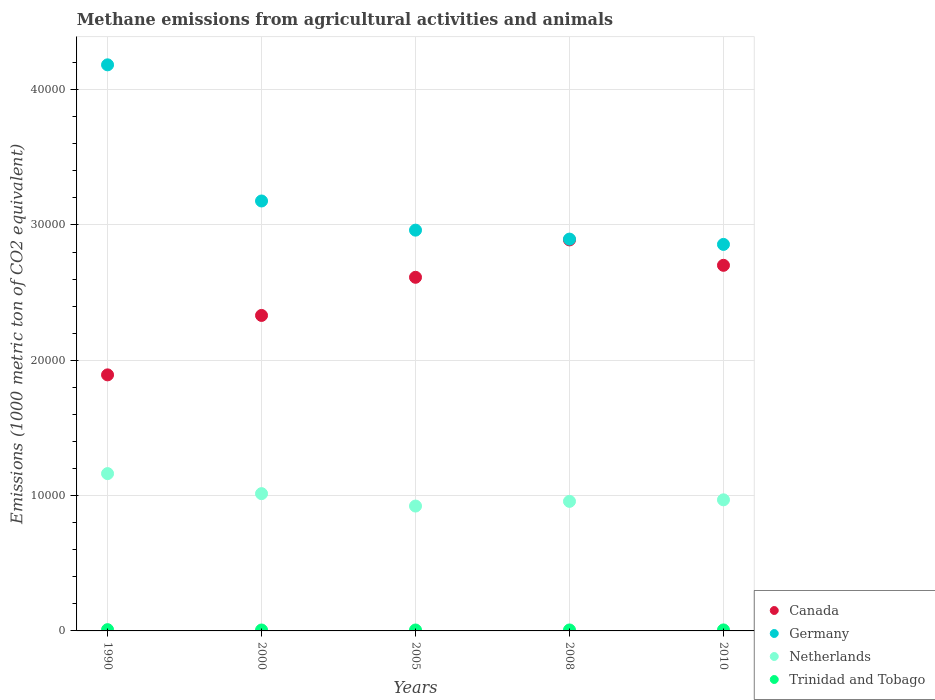How many different coloured dotlines are there?
Provide a succinct answer. 4. Is the number of dotlines equal to the number of legend labels?
Make the answer very short. Yes. What is the amount of methane emitted in Germany in 2008?
Ensure brevity in your answer.  2.90e+04. Across all years, what is the maximum amount of methane emitted in Canada?
Your response must be concise. 2.89e+04. Across all years, what is the minimum amount of methane emitted in Netherlands?
Offer a terse response. 9228. What is the total amount of methane emitted in Germany in the graph?
Give a very brief answer. 1.61e+05. What is the difference between the amount of methane emitted in Netherlands in 2000 and that in 2010?
Provide a succinct answer. 457. What is the difference between the amount of methane emitted in Canada in 2000 and the amount of methane emitted in Germany in 1990?
Keep it short and to the point. -1.85e+04. What is the average amount of methane emitted in Trinidad and Tobago per year?
Your answer should be very brief. 74.64. In the year 2005, what is the difference between the amount of methane emitted in Netherlands and amount of methane emitted in Germany?
Offer a terse response. -2.04e+04. In how many years, is the amount of methane emitted in Netherlands greater than 12000 1000 metric ton?
Your answer should be very brief. 0. What is the ratio of the amount of methane emitted in Trinidad and Tobago in 1990 to that in 2008?
Provide a short and direct response. 1.31. What is the difference between the highest and the second highest amount of methane emitted in Germany?
Your answer should be very brief. 1.01e+04. What is the difference between the highest and the lowest amount of methane emitted in Germany?
Offer a very short reply. 1.33e+04. Is the sum of the amount of methane emitted in Canada in 1990 and 2005 greater than the maximum amount of methane emitted in Trinidad and Tobago across all years?
Give a very brief answer. Yes. Is the amount of methane emitted in Canada strictly greater than the amount of methane emitted in Netherlands over the years?
Your answer should be very brief. Yes. Is the amount of methane emitted in Trinidad and Tobago strictly less than the amount of methane emitted in Canada over the years?
Provide a succinct answer. Yes. How many dotlines are there?
Provide a short and direct response. 4. How many years are there in the graph?
Your answer should be compact. 5. Does the graph contain any zero values?
Make the answer very short. No. What is the title of the graph?
Make the answer very short. Methane emissions from agricultural activities and animals. Does "Ukraine" appear as one of the legend labels in the graph?
Your answer should be very brief. No. What is the label or title of the X-axis?
Keep it short and to the point. Years. What is the label or title of the Y-axis?
Make the answer very short. Emissions (1000 metric ton of CO2 equivalent). What is the Emissions (1000 metric ton of CO2 equivalent) of Canada in 1990?
Your answer should be very brief. 1.89e+04. What is the Emissions (1000 metric ton of CO2 equivalent) in Germany in 1990?
Offer a terse response. 4.18e+04. What is the Emissions (1000 metric ton of CO2 equivalent) in Netherlands in 1990?
Provide a succinct answer. 1.16e+04. What is the Emissions (1000 metric ton of CO2 equivalent) in Trinidad and Tobago in 1990?
Your answer should be compact. 92.7. What is the Emissions (1000 metric ton of CO2 equivalent) in Canada in 2000?
Offer a very short reply. 2.33e+04. What is the Emissions (1000 metric ton of CO2 equivalent) in Germany in 2000?
Your response must be concise. 3.18e+04. What is the Emissions (1000 metric ton of CO2 equivalent) of Netherlands in 2000?
Your answer should be very brief. 1.01e+04. What is the Emissions (1000 metric ton of CO2 equivalent) of Trinidad and Tobago in 2000?
Your response must be concise. 68. What is the Emissions (1000 metric ton of CO2 equivalent) of Canada in 2005?
Ensure brevity in your answer.  2.61e+04. What is the Emissions (1000 metric ton of CO2 equivalent) of Germany in 2005?
Offer a very short reply. 2.96e+04. What is the Emissions (1000 metric ton of CO2 equivalent) of Netherlands in 2005?
Your answer should be compact. 9228. What is the Emissions (1000 metric ton of CO2 equivalent) of Trinidad and Tobago in 2005?
Provide a succinct answer. 68.1. What is the Emissions (1000 metric ton of CO2 equivalent) of Canada in 2008?
Provide a short and direct response. 2.89e+04. What is the Emissions (1000 metric ton of CO2 equivalent) of Germany in 2008?
Provide a succinct answer. 2.90e+04. What is the Emissions (1000 metric ton of CO2 equivalent) of Netherlands in 2008?
Ensure brevity in your answer.  9574.5. What is the Emissions (1000 metric ton of CO2 equivalent) in Canada in 2010?
Your response must be concise. 2.70e+04. What is the Emissions (1000 metric ton of CO2 equivalent) of Germany in 2010?
Offer a terse response. 2.86e+04. What is the Emissions (1000 metric ton of CO2 equivalent) of Netherlands in 2010?
Keep it short and to the point. 9687.8. What is the Emissions (1000 metric ton of CO2 equivalent) of Trinidad and Tobago in 2010?
Your answer should be very brief. 73.4. Across all years, what is the maximum Emissions (1000 metric ton of CO2 equivalent) in Canada?
Make the answer very short. 2.89e+04. Across all years, what is the maximum Emissions (1000 metric ton of CO2 equivalent) of Germany?
Keep it short and to the point. 4.18e+04. Across all years, what is the maximum Emissions (1000 metric ton of CO2 equivalent) in Netherlands?
Your answer should be compact. 1.16e+04. Across all years, what is the maximum Emissions (1000 metric ton of CO2 equivalent) in Trinidad and Tobago?
Make the answer very short. 92.7. Across all years, what is the minimum Emissions (1000 metric ton of CO2 equivalent) in Canada?
Your answer should be compact. 1.89e+04. Across all years, what is the minimum Emissions (1000 metric ton of CO2 equivalent) in Germany?
Ensure brevity in your answer.  2.86e+04. Across all years, what is the minimum Emissions (1000 metric ton of CO2 equivalent) in Netherlands?
Keep it short and to the point. 9228. What is the total Emissions (1000 metric ton of CO2 equivalent) of Canada in the graph?
Your answer should be very brief. 1.24e+05. What is the total Emissions (1000 metric ton of CO2 equivalent) of Germany in the graph?
Make the answer very short. 1.61e+05. What is the total Emissions (1000 metric ton of CO2 equivalent) in Netherlands in the graph?
Give a very brief answer. 5.03e+04. What is the total Emissions (1000 metric ton of CO2 equivalent) in Trinidad and Tobago in the graph?
Your response must be concise. 373.2. What is the difference between the Emissions (1000 metric ton of CO2 equivalent) of Canada in 1990 and that in 2000?
Keep it short and to the point. -4391.7. What is the difference between the Emissions (1000 metric ton of CO2 equivalent) of Germany in 1990 and that in 2000?
Offer a terse response. 1.01e+04. What is the difference between the Emissions (1000 metric ton of CO2 equivalent) of Netherlands in 1990 and that in 2000?
Keep it short and to the point. 1481.2. What is the difference between the Emissions (1000 metric ton of CO2 equivalent) of Trinidad and Tobago in 1990 and that in 2000?
Provide a succinct answer. 24.7. What is the difference between the Emissions (1000 metric ton of CO2 equivalent) in Canada in 1990 and that in 2005?
Offer a very short reply. -7210.8. What is the difference between the Emissions (1000 metric ton of CO2 equivalent) of Germany in 1990 and that in 2005?
Keep it short and to the point. 1.22e+04. What is the difference between the Emissions (1000 metric ton of CO2 equivalent) of Netherlands in 1990 and that in 2005?
Offer a very short reply. 2398. What is the difference between the Emissions (1000 metric ton of CO2 equivalent) in Trinidad and Tobago in 1990 and that in 2005?
Make the answer very short. 24.6. What is the difference between the Emissions (1000 metric ton of CO2 equivalent) in Canada in 1990 and that in 2008?
Ensure brevity in your answer.  -9973.1. What is the difference between the Emissions (1000 metric ton of CO2 equivalent) of Germany in 1990 and that in 2008?
Your answer should be very brief. 1.29e+04. What is the difference between the Emissions (1000 metric ton of CO2 equivalent) in Netherlands in 1990 and that in 2008?
Your response must be concise. 2051.5. What is the difference between the Emissions (1000 metric ton of CO2 equivalent) in Trinidad and Tobago in 1990 and that in 2008?
Offer a very short reply. 21.7. What is the difference between the Emissions (1000 metric ton of CO2 equivalent) of Canada in 1990 and that in 2010?
Offer a terse response. -8095.8. What is the difference between the Emissions (1000 metric ton of CO2 equivalent) in Germany in 1990 and that in 2010?
Your answer should be very brief. 1.33e+04. What is the difference between the Emissions (1000 metric ton of CO2 equivalent) of Netherlands in 1990 and that in 2010?
Offer a terse response. 1938.2. What is the difference between the Emissions (1000 metric ton of CO2 equivalent) in Trinidad and Tobago in 1990 and that in 2010?
Offer a terse response. 19.3. What is the difference between the Emissions (1000 metric ton of CO2 equivalent) of Canada in 2000 and that in 2005?
Your answer should be very brief. -2819.1. What is the difference between the Emissions (1000 metric ton of CO2 equivalent) in Germany in 2000 and that in 2005?
Provide a short and direct response. 2155.4. What is the difference between the Emissions (1000 metric ton of CO2 equivalent) in Netherlands in 2000 and that in 2005?
Offer a very short reply. 916.8. What is the difference between the Emissions (1000 metric ton of CO2 equivalent) in Trinidad and Tobago in 2000 and that in 2005?
Make the answer very short. -0.1. What is the difference between the Emissions (1000 metric ton of CO2 equivalent) in Canada in 2000 and that in 2008?
Offer a very short reply. -5581.4. What is the difference between the Emissions (1000 metric ton of CO2 equivalent) in Germany in 2000 and that in 2008?
Your response must be concise. 2816.4. What is the difference between the Emissions (1000 metric ton of CO2 equivalent) of Netherlands in 2000 and that in 2008?
Offer a terse response. 570.3. What is the difference between the Emissions (1000 metric ton of CO2 equivalent) of Trinidad and Tobago in 2000 and that in 2008?
Make the answer very short. -3. What is the difference between the Emissions (1000 metric ton of CO2 equivalent) of Canada in 2000 and that in 2010?
Your answer should be very brief. -3704.1. What is the difference between the Emissions (1000 metric ton of CO2 equivalent) of Germany in 2000 and that in 2010?
Offer a terse response. 3209.1. What is the difference between the Emissions (1000 metric ton of CO2 equivalent) of Netherlands in 2000 and that in 2010?
Keep it short and to the point. 457. What is the difference between the Emissions (1000 metric ton of CO2 equivalent) of Canada in 2005 and that in 2008?
Provide a short and direct response. -2762.3. What is the difference between the Emissions (1000 metric ton of CO2 equivalent) of Germany in 2005 and that in 2008?
Make the answer very short. 661. What is the difference between the Emissions (1000 metric ton of CO2 equivalent) in Netherlands in 2005 and that in 2008?
Provide a succinct answer. -346.5. What is the difference between the Emissions (1000 metric ton of CO2 equivalent) of Canada in 2005 and that in 2010?
Offer a terse response. -885. What is the difference between the Emissions (1000 metric ton of CO2 equivalent) in Germany in 2005 and that in 2010?
Make the answer very short. 1053.7. What is the difference between the Emissions (1000 metric ton of CO2 equivalent) in Netherlands in 2005 and that in 2010?
Make the answer very short. -459.8. What is the difference between the Emissions (1000 metric ton of CO2 equivalent) in Canada in 2008 and that in 2010?
Provide a short and direct response. 1877.3. What is the difference between the Emissions (1000 metric ton of CO2 equivalent) in Germany in 2008 and that in 2010?
Your answer should be very brief. 392.7. What is the difference between the Emissions (1000 metric ton of CO2 equivalent) of Netherlands in 2008 and that in 2010?
Offer a very short reply. -113.3. What is the difference between the Emissions (1000 metric ton of CO2 equivalent) of Canada in 1990 and the Emissions (1000 metric ton of CO2 equivalent) of Germany in 2000?
Provide a short and direct response. -1.29e+04. What is the difference between the Emissions (1000 metric ton of CO2 equivalent) of Canada in 1990 and the Emissions (1000 metric ton of CO2 equivalent) of Netherlands in 2000?
Give a very brief answer. 8778.7. What is the difference between the Emissions (1000 metric ton of CO2 equivalent) of Canada in 1990 and the Emissions (1000 metric ton of CO2 equivalent) of Trinidad and Tobago in 2000?
Provide a short and direct response. 1.89e+04. What is the difference between the Emissions (1000 metric ton of CO2 equivalent) of Germany in 1990 and the Emissions (1000 metric ton of CO2 equivalent) of Netherlands in 2000?
Keep it short and to the point. 3.17e+04. What is the difference between the Emissions (1000 metric ton of CO2 equivalent) in Germany in 1990 and the Emissions (1000 metric ton of CO2 equivalent) in Trinidad and Tobago in 2000?
Provide a succinct answer. 4.18e+04. What is the difference between the Emissions (1000 metric ton of CO2 equivalent) in Netherlands in 1990 and the Emissions (1000 metric ton of CO2 equivalent) in Trinidad and Tobago in 2000?
Your answer should be compact. 1.16e+04. What is the difference between the Emissions (1000 metric ton of CO2 equivalent) of Canada in 1990 and the Emissions (1000 metric ton of CO2 equivalent) of Germany in 2005?
Your response must be concise. -1.07e+04. What is the difference between the Emissions (1000 metric ton of CO2 equivalent) of Canada in 1990 and the Emissions (1000 metric ton of CO2 equivalent) of Netherlands in 2005?
Ensure brevity in your answer.  9695.5. What is the difference between the Emissions (1000 metric ton of CO2 equivalent) in Canada in 1990 and the Emissions (1000 metric ton of CO2 equivalent) in Trinidad and Tobago in 2005?
Your answer should be very brief. 1.89e+04. What is the difference between the Emissions (1000 metric ton of CO2 equivalent) in Germany in 1990 and the Emissions (1000 metric ton of CO2 equivalent) in Netherlands in 2005?
Your answer should be very brief. 3.26e+04. What is the difference between the Emissions (1000 metric ton of CO2 equivalent) in Germany in 1990 and the Emissions (1000 metric ton of CO2 equivalent) in Trinidad and Tobago in 2005?
Your response must be concise. 4.18e+04. What is the difference between the Emissions (1000 metric ton of CO2 equivalent) in Netherlands in 1990 and the Emissions (1000 metric ton of CO2 equivalent) in Trinidad and Tobago in 2005?
Offer a terse response. 1.16e+04. What is the difference between the Emissions (1000 metric ton of CO2 equivalent) in Canada in 1990 and the Emissions (1000 metric ton of CO2 equivalent) in Germany in 2008?
Provide a short and direct response. -1.00e+04. What is the difference between the Emissions (1000 metric ton of CO2 equivalent) in Canada in 1990 and the Emissions (1000 metric ton of CO2 equivalent) in Netherlands in 2008?
Ensure brevity in your answer.  9349. What is the difference between the Emissions (1000 metric ton of CO2 equivalent) of Canada in 1990 and the Emissions (1000 metric ton of CO2 equivalent) of Trinidad and Tobago in 2008?
Your response must be concise. 1.89e+04. What is the difference between the Emissions (1000 metric ton of CO2 equivalent) in Germany in 1990 and the Emissions (1000 metric ton of CO2 equivalent) in Netherlands in 2008?
Your response must be concise. 3.23e+04. What is the difference between the Emissions (1000 metric ton of CO2 equivalent) of Germany in 1990 and the Emissions (1000 metric ton of CO2 equivalent) of Trinidad and Tobago in 2008?
Your answer should be compact. 4.18e+04. What is the difference between the Emissions (1000 metric ton of CO2 equivalent) of Netherlands in 1990 and the Emissions (1000 metric ton of CO2 equivalent) of Trinidad and Tobago in 2008?
Offer a very short reply. 1.16e+04. What is the difference between the Emissions (1000 metric ton of CO2 equivalent) of Canada in 1990 and the Emissions (1000 metric ton of CO2 equivalent) of Germany in 2010?
Provide a short and direct response. -9641. What is the difference between the Emissions (1000 metric ton of CO2 equivalent) of Canada in 1990 and the Emissions (1000 metric ton of CO2 equivalent) of Netherlands in 2010?
Give a very brief answer. 9235.7. What is the difference between the Emissions (1000 metric ton of CO2 equivalent) of Canada in 1990 and the Emissions (1000 metric ton of CO2 equivalent) of Trinidad and Tobago in 2010?
Keep it short and to the point. 1.89e+04. What is the difference between the Emissions (1000 metric ton of CO2 equivalent) of Germany in 1990 and the Emissions (1000 metric ton of CO2 equivalent) of Netherlands in 2010?
Ensure brevity in your answer.  3.21e+04. What is the difference between the Emissions (1000 metric ton of CO2 equivalent) in Germany in 1990 and the Emissions (1000 metric ton of CO2 equivalent) in Trinidad and Tobago in 2010?
Offer a very short reply. 4.18e+04. What is the difference between the Emissions (1000 metric ton of CO2 equivalent) in Netherlands in 1990 and the Emissions (1000 metric ton of CO2 equivalent) in Trinidad and Tobago in 2010?
Your answer should be very brief. 1.16e+04. What is the difference between the Emissions (1000 metric ton of CO2 equivalent) in Canada in 2000 and the Emissions (1000 metric ton of CO2 equivalent) in Germany in 2005?
Offer a very short reply. -6303. What is the difference between the Emissions (1000 metric ton of CO2 equivalent) of Canada in 2000 and the Emissions (1000 metric ton of CO2 equivalent) of Netherlands in 2005?
Make the answer very short. 1.41e+04. What is the difference between the Emissions (1000 metric ton of CO2 equivalent) of Canada in 2000 and the Emissions (1000 metric ton of CO2 equivalent) of Trinidad and Tobago in 2005?
Your answer should be compact. 2.32e+04. What is the difference between the Emissions (1000 metric ton of CO2 equivalent) of Germany in 2000 and the Emissions (1000 metric ton of CO2 equivalent) of Netherlands in 2005?
Provide a short and direct response. 2.25e+04. What is the difference between the Emissions (1000 metric ton of CO2 equivalent) in Germany in 2000 and the Emissions (1000 metric ton of CO2 equivalent) in Trinidad and Tobago in 2005?
Ensure brevity in your answer.  3.17e+04. What is the difference between the Emissions (1000 metric ton of CO2 equivalent) in Netherlands in 2000 and the Emissions (1000 metric ton of CO2 equivalent) in Trinidad and Tobago in 2005?
Your answer should be very brief. 1.01e+04. What is the difference between the Emissions (1000 metric ton of CO2 equivalent) in Canada in 2000 and the Emissions (1000 metric ton of CO2 equivalent) in Germany in 2008?
Provide a short and direct response. -5642. What is the difference between the Emissions (1000 metric ton of CO2 equivalent) in Canada in 2000 and the Emissions (1000 metric ton of CO2 equivalent) in Netherlands in 2008?
Keep it short and to the point. 1.37e+04. What is the difference between the Emissions (1000 metric ton of CO2 equivalent) in Canada in 2000 and the Emissions (1000 metric ton of CO2 equivalent) in Trinidad and Tobago in 2008?
Offer a very short reply. 2.32e+04. What is the difference between the Emissions (1000 metric ton of CO2 equivalent) in Germany in 2000 and the Emissions (1000 metric ton of CO2 equivalent) in Netherlands in 2008?
Offer a very short reply. 2.22e+04. What is the difference between the Emissions (1000 metric ton of CO2 equivalent) in Germany in 2000 and the Emissions (1000 metric ton of CO2 equivalent) in Trinidad and Tobago in 2008?
Your answer should be very brief. 3.17e+04. What is the difference between the Emissions (1000 metric ton of CO2 equivalent) in Netherlands in 2000 and the Emissions (1000 metric ton of CO2 equivalent) in Trinidad and Tobago in 2008?
Offer a very short reply. 1.01e+04. What is the difference between the Emissions (1000 metric ton of CO2 equivalent) in Canada in 2000 and the Emissions (1000 metric ton of CO2 equivalent) in Germany in 2010?
Your answer should be very brief. -5249.3. What is the difference between the Emissions (1000 metric ton of CO2 equivalent) of Canada in 2000 and the Emissions (1000 metric ton of CO2 equivalent) of Netherlands in 2010?
Provide a short and direct response. 1.36e+04. What is the difference between the Emissions (1000 metric ton of CO2 equivalent) of Canada in 2000 and the Emissions (1000 metric ton of CO2 equivalent) of Trinidad and Tobago in 2010?
Ensure brevity in your answer.  2.32e+04. What is the difference between the Emissions (1000 metric ton of CO2 equivalent) of Germany in 2000 and the Emissions (1000 metric ton of CO2 equivalent) of Netherlands in 2010?
Offer a terse response. 2.21e+04. What is the difference between the Emissions (1000 metric ton of CO2 equivalent) of Germany in 2000 and the Emissions (1000 metric ton of CO2 equivalent) of Trinidad and Tobago in 2010?
Provide a short and direct response. 3.17e+04. What is the difference between the Emissions (1000 metric ton of CO2 equivalent) in Netherlands in 2000 and the Emissions (1000 metric ton of CO2 equivalent) in Trinidad and Tobago in 2010?
Give a very brief answer. 1.01e+04. What is the difference between the Emissions (1000 metric ton of CO2 equivalent) of Canada in 2005 and the Emissions (1000 metric ton of CO2 equivalent) of Germany in 2008?
Your answer should be compact. -2822.9. What is the difference between the Emissions (1000 metric ton of CO2 equivalent) of Canada in 2005 and the Emissions (1000 metric ton of CO2 equivalent) of Netherlands in 2008?
Your answer should be compact. 1.66e+04. What is the difference between the Emissions (1000 metric ton of CO2 equivalent) of Canada in 2005 and the Emissions (1000 metric ton of CO2 equivalent) of Trinidad and Tobago in 2008?
Keep it short and to the point. 2.61e+04. What is the difference between the Emissions (1000 metric ton of CO2 equivalent) of Germany in 2005 and the Emissions (1000 metric ton of CO2 equivalent) of Netherlands in 2008?
Offer a very short reply. 2.00e+04. What is the difference between the Emissions (1000 metric ton of CO2 equivalent) in Germany in 2005 and the Emissions (1000 metric ton of CO2 equivalent) in Trinidad and Tobago in 2008?
Keep it short and to the point. 2.95e+04. What is the difference between the Emissions (1000 metric ton of CO2 equivalent) of Netherlands in 2005 and the Emissions (1000 metric ton of CO2 equivalent) of Trinidad and Tobago in 2008?
Offer a very short reply. 9157. What is the difference between the Emissions (1000 metric ton of CO2 equivalent) of Canada in 2005 and the Emissions (1000 metric ton of CO2 equivalent) of Germany in 2010?
Provide a short and direct response. -2430.2. What is the difference between the Emissions (1000 metric ton of CO2 equivalent) in Canada in 2005 and the Emissions (1000 metric ton of CO2 equivalent) in Netherlands in 2010?
Offer a terse response. 1.64e+04. What is the difference between the Emissions (1000 metric ton of CO2 equivalent) in Canada in 2005 and the Emissions (1000 metric ton of CO2 equivalent) in Trinidad and Tobago in 2010?
Your answer should be very brief. 2.61e+04. What is the difference between the Emissions (1000 metric ton of CO2 equivalent) in Germany in 2005 and the Emissions (1000 metric ton of CO2 equivalent) in Netherlands in 2010?
Offer a very short reply. 1.99e+04. What is the difference between the Emissions (1000 metric ton of CO2 equivalent) of Germany in 2005 and the Emissions (1000 metric ton of CO2 equivalent) of Trinidad and Tobago in 2010?
Your answer should be very brief. 2.95e+04. What is the difference between the Emissions (1000 metric ton of CO2 equivalent) of Netherlands in 2005 and the Emissions (1000 metric ton of CO2 equivalent) of Trinidad and Tobago in 2010?
Provide a short and direct response. 9154.6. What is the difference between the Emissions (1000 metric ton of CO2 equivalent) of Canada in 2008 and the Emissions (1000 metric ton of CO2 equivalent) of Germany in 2010?
Keep it short and to the point. 332.1. What is the difference between the Emissions (1000 metric ton of CO2 equivalent) in Canada in 2008 and the Emissions (1000 metric ton of CO2 equivalent) in Netherlands in 2010?
Make the answer very short. 1.92e+04. What is the difference between the Emissions (1000 metric ton of CO2 equivalent) of Canada in 2008 and the Emissions (1000 metric ton of CO2 equivalent) of Trinidad and Tobago in 2010?
Your answer should be very brief. 2.88e+04. What is the difference between the Emissions (1000 metric ton of CO2 equivalent) in Germany in 2008 and the Emissions (1000 metric ton of CO2 equivalent) in Netherlands in 2010?
Offer a very short reply. 1.93e+04. What is the difference between the Emissions (1000 metric ton of CO2 equivalent) in Germany in 2008 and the Emissions (1000 metric ton of CO2 equivalent) in Trinidad and Tobago in 2010?
Your answer should be compact. 2.89e+04. What is the difference between the Emissions (1000 metric ton of CO2 equivalent) in Netherlands in 2008 and the Emissions (1000 metric ton of CO2 equivalent) in Trinidad and Tobago in 2010?
Make the answer very short. 9501.1. What is the average Emissions (1000 metric ton of CO2 equivalent) in Canada per year?
Your answer should be very brief. 2.49e+04. What is the average Emissions (1000 metric ton of CO2 equivalent) in Germany per year?
Make the answer very short. 3.21e+04. What is the average Emissions (1000 metric ton of CO2 equivalent) of Netherlands per year?
Offer a very short reply. 1.01e+04. What is the average Emissions (1000 metric ton of CO2 equivalent) of Trinidad and Tobago per year?
Make the answer very short. 74.64. In the year 1990, what is the difference between the Emissions (1000 metric ton of CO2 equivalent) of Canada and Emissions (1000 metric ton of CO2 equivalent) of Germany?
Make the answer very short. -2.29e+04. In the year 1990, what is the difference between the Emissions (1000 metric ton of CO2 equivalent) of Canada and Emissions (1000 metric ton of CO2 equivalent) of Netherlands?
Offer a terse response. 7297.5. In the year 1990, what is the difference between the Emissions (1000 metric ton of CO2 equivalent) of Canada and Emissions (1000 metric ton of CO2 equivalent) of Trinidad and Tobago?
Your answer should be compact. 1.88e+04. In the year 1990, what is the difference between the Emissions (1000 metric ton of CO2 equivalent) in Germany and Emissions (1000 metric ton of CO2 equivalent) in Netherlands?
Offer a terse response. 3.02e+04. In the year 1990, what is the difference between the Emissions (1000 metric ton of CO2 equivalent) in Germany and Emissions (1000 metric ton of CO2 equivalent) in Trinidad and Tobago?
Your response must be concise. 4.17e+04. In the year 1990, what is the difference between the Emissions (1000 metric ton of CO2 equivalent) of Netherlands and Emissions (1000 metric ton of CO2 equivalent) of Trinidad and Tobago?
Your answer should be very brief. 1.15e+04. In the year 2000, what is the difference between the Emissions (1000 metric ton of CO2 equivalent) of Canada and Emissions (1000 metric ton of CO2 equivalent) of Germany?
Provide a short and direct response. -8458.4. In the year 2000, what is the difference between the Emissions (1000 metric ton of CO2 equivalent) of Canada and Emissions (1000 metric ton of CO2 equivalent) of Netherlands?
Provide a short and direct response. 1.32e+04. In the year 2000, what is the difference between the Emissions (1000 metric ton of CO2 equivalent) of Canada and Emissions (1000 metric ton of CO2 equivalent) of Trinidad and Tobago?
Provide a short and direct response. 2.32e+04. In the year 2000, what is the difference between the Emissions (1000 metric ton of CO2 equivalent) of Germany and Emissions (1000 metric ton of CO2 equivalent) of Netherlands?
Give a very brief answer. 2.16e+04. In the year 2000, what is the difference between the Emissions (1000 metric ton of CO2 equivalent) of Germany and Emissions (1000 metric ton of CO2 equivalent) of Trinidad and Tobago?
Your answer should be very brief. 3.17e+04. In the year 2000, what is the difference between the Emissions (1000 metric ton of CO2 equivalent) in Netherlands and Emissions (1000 metric ton of CO2 equivalent) in Trinidad and Tobago?
Ensure brevity in your answer.  1.01e+04. In the year 2005, what is the difference between the Emissions (1000 metric ton of CO2 equivalent) of Canada and Emissions (1000 metric ton of CO2 equivalent) of Germany?
Keep it short and to the point. -3483.9. In the year 2005, what is the difference between the Emissions (1000 metric ton of CO2 equivalent) in Canada and Emissions (1000 metric ton of CO2 equivalent) in Netherlands?
Provide a short and direct response. 1.69e+04. In the year 2005, what is the difference between the Emissions (1000 metric ton of CO2 equivalent) of Canada and Emissions (1000 metric ton of CO2 equivalent) of Trinidad and Tobago?
Provide a short and direct response. 2.61e+04. In the year 2005, what is the difference between the Emissions (1000 metric ton of CO2 equivalent) of Germany and Emissions (1000 metric ton of CO2 equivalent) of Netherlands?
Provide a short and direct response. 2.04e+04. In the year 2005, what is the difference between the Emissions (1000 metric ton of CO2 equivalent) of Germany and Emissions (1000 metric ton of CO2 equivalent) of Trinidad and Tobago?
Offer a very short reply. 2.96e+04. In the year 2005, what is the difference between the Emissions (1000 metric ton of CO2 equivalent) of Netherlands and Emissions (1000 metric ton of CO2 equivalent) of Trinidad and Tobago?
Offer a very short reply. 9159.9. In the year 2008, what is the difference between the Emissions (1000 metric ton of CO2 equivalent) of Canada and Emissions (1000 metric ton of CO2 equivalent) of Germany?
Give a very brief answer. -60.6. In the year 2008, what is the difference between the Emissions (1000 metric ton of CO2 equivalent) of Canada and Emissions (1000 metric ton of CO2 equivalent) of Netherlands?
Keep it short and to the point. 1.93e+04. In the year 2008, what is the difference between the Emissions (1000 metric ton of CO2 equivalent) in Canada and Emissions (1000 metric ton of CO2 equivalent) in Trinidad and Tobago?
Keep it short and to the point. 2.88e+04. In the year 2008, what is the difference between the Emissions (1000 metric ton of CO2 equivalent) of Germany and Emissions (1000 metric ton of CO2 equivalent) of Netherlands?
Offer a terse response. 1.94e+04. In the year 2008, what is the difference between the Emissions (1000 metric ton of CO2 equivalent) in Germany and Emissions (1000 metric ton of CO2 equivalent) in Trinidad and Tobago?
Your answer should be compact. 2.89e+04. In the year 2008, what is the difference between the Emissions (1000 metric ton of CO2 equivalent) in Netherlands and Emissions (1000 metric ton of CO2 equivalent) in Trinidad and Tobago?
Offer a very short reply. 9503.5. In the year 2010, what is the difference between the Emissions (1000 metric ton of CO2 equivalent) of Canada and Emissions (1000 metric ton of CO2 equivalent) of Germany?
Your response must be concise. -1545.2. In the year 2010, what is the difference between the Emissions (1000 metric ton of CO2 equivalent) in Canada and Emissions (1000 metric ton of CO2 equivalent) in Netherlands?
Offer a terse response. 1.73e+04. In the year 2010, what is the difference between the Emissions (1000 metric ton of CO2 equivalent) of Canada and Emissions (1000 metric ton of CO2 equivalent) of Trinidad and Tobago?
Your response must be concise. 2.69e+04. In the year 2010, what is the difference between the Emissions (1000 metric ton of CO2 equivalent) in Germany and Emissions (1000 metric ton of CO2 equivalent) in Netherlands?
Keep it short and to the point. 1.89e+04. In the year 2010, what is the difference between the Emissions (1000 metric ton of CO2 equivalent) of Germany and Emissions (1000 metric ton of CO2 equivalent) of Trinidad and Tobago?
Give a very brief answer. 2.85e+04. In the year 2010, what is the difference between the Emissions (1000 metric ton of CO2 equivalent) of Netherlands and Emissions (1000 metric ton of CO2 equivalent) of Trinidad and Tobago?
Offer a very short reply. 9614.4. What is the ratio of the Emissions (1000 metric ton of CO2 equivalent) in Canada in 1990 to that in 2000?
Give a very brief answer. 0.81. What is the ratio of the Emissions (1000 metric ton of CO2 equivalent) in Germany in 1990 to that in 2000?
Your response must be concise. 1.32. What is the ratio of the Emissions (1000 metric ton of CO2 equivalent) of Netherlands in 1990 to that in 2000?
Your answer should be compact. 1.15. What is the ratio of the Emissions (1000 metric ton of CO2 equivalent) of Trinidad and Tobago in 1990 to that in 2000?
Keep it short and to the point. 1.36. What is the ratio of the Emissions (1000 metric ton of CO2 equivalent) of Canada in 1990 to that in 2005?
Ensure brevity in your answer.  0.72. What is the ratio of the Emissions (1000 metric ton of CO2 equivalent) in Germany in 1990 to that in 2005?
Ensure brevity in your answer.  1.41. What is the ratio of the Emissions (1000 metric ton of CO2 equivalent) of Netherlands in 1990 to that in 2005?
Provide a short and direct response. 1.26. What is the ratio of the Emissions (1000 metric ton of CO2 equivalent) of Trinidad and Tobago in 1990 to that in 2005?
Offer a very short reply. 1.36. What is the ratio of the Emissions (1000 metric ton of CO2 equivalent) in Canada in 1990 to that in 2008?
Keep it short and to the point. 0.65. What is the ratio of the Emissions (1000 metric ton of CO2 equivalent) in Germany in 1990 to that in 2008?
Make the answer very short. 1.44. What is the ratio of the Emissions (1000 metric ton of CO2 equivalent) of Netherlands in 1990 to that in 2008?
Offer a very short reply. 1.21. What is the ratio of the Emissions (1000 metric ton of CO2 equivalent) of Trinidad and Tobago in 1990 to that in 2008?
Offer a terse response. 1.31. What is the ratio of the Emissions (1000 metric ton of CO2 equivalent) in Canada in 1990 to that in 2010?
Your answer should be very brief. 0.7. What is the ratio of the Emissions (1000 metric ton of CO2 equivalent) in Germany in 1990 to that in 2010?
Ensure brevity in your answer.  1.46. What is the ratio of the Emissions (1000 metric ton of CO2 equivalent) in Netherlands in 1990 to that in 2010?
Keep it short and to the point. 1.2. What is the ratio of the Emissions (1000 metric ton of CO2 equivalent) in Trinidad and Tobago in 1990 to that in 2010?
Keep it short and to the point. 1.26. What is the ratio of the Emissions (1000 metric ton of CO2 equivalent) in Canada in 2000 to that in 2005?
Your response must be concise. 0.89. What is the ratio of the Emissions (1000 metric ton of CO2 equivalent) in Germany in 2000 to that in 2005?
Offer a terse response. 1.07. What is the ratio of the Emissions (1000 metric ton of CO2 equivalent) in Netherlands in 2000 to that in 2005?
Your answer should be very brief. 1.1. What is the ratio of the Emissions (1000 metric ton of CO2 equivalent) of Canada in 2000 to that in 2008?
Provide a succinct answer. 0.81. What is the ratio of the Emissions (1000 metric ton of CO2 equivalent) of Germany in 2000 to that in 2008?
Give a very brief answer. 1.1. What is the ratio of the Emissions (1000 metric ton of CO2 equivalent) in Netherlands in 2000 to that in 2008?
Provide a short and direct response. 1.06. What is the ratio of the Emissions (1000 metric ton of CO2 equivalent) in Trinidad and Tobago in 2000 to that in 2008?
Make the answer very short. 0.96. What is the ratio of the Emissions (1000 metric ton of CO2 equivalent) of Canada in 2000 to that in 2010?
Provide a succinct answer. 0.86. What is the ratio of the Emissions (1000 metric ton of CO2 equivalent) of Germany in 2000 to that in 2010?
Ensure brevity in your answer.  1.11. What is the ratio of the Emissions (1000 metric ton of CO2 equivalent) of Netherlands in 2000 to that in 2010?
Keep it short and to the point. 1.05. What is the ratio of the Emissions (1000 metric ton of CO2 equivalent) in Trinidad and Tobago in 2000 to that in 2010?
Provide a short and direct response. 0.93. What is the ratio of the Emissions (1000 metric ton of CO2 equivalent) of Canada in 2005 to that in 2008?
Provide a short and direct response. 0.9. What is the ratio of the Emissions (1000 metric ton of CO2 equivalent) of Germany in 2005 to that in 2008?
Give a very brief answer. 1.02. What is the ratio of the Emissions (1000 metric ton of CO2 equivalent) of Netherlands in 2005 to that in 2008?
Give a very brief answer. 0.96. What is the ratio of the Emissions (1000 metric ton of CO2 equivalent) of Trinidad and Tobago in 2005 to that in 2008?
Make the answer very short. 0.96. What is the ratio of the Emissions (1000 metric ton of CO2 equivalent) of Canada in 2005 to that in 2010?
Your response must be concise. 0.97. What is the ratio of the Emissions (1000 metric ton of CO2 equivalent) of Germany in 2005 to that in 2010?
Keep it short and to the point. 1.04. What is the ratio of the Emissions (1000 metric ton of CO2 equivalent) of Netherlands in 2005 to that in 2010?
Provide a succinct answer. 0.95. What is the ratio of the Emissions (1000 metric ton of CO2 equivalent) in Trinidad and Tobago in 2005 to that in 2010?
Your answer should be very brief. 0.93. What is the ratio of the Emissions (1000 metric ton of CO2 equivalent) in Canada in 2008 to that in 2010?
Make the answer very short. 1.07. What is the ratio of the Emissions (1000 metric ton of CO2 equivalent) of Germany in 2008 to that in 2010?
Make the answer very short. 1.01. What is the ratio of the Emissions (1000 metric ton of CO2 equivalent) of Netherlands in 2008 to that in 2010?
Give a very brief answer. 0.99. What is the ratio of the Emissions (1000 metric ton of CO2 equivalent) in Trinidad and Tobago in 2008 to that in 2010?
Ensure brevity in your answer.  0.97. What is the difference between the highest and the second highest Emissions (1000 metric ton of CO2 equivalent) of Canada?
Offer a very short reply. 1877.3. What is the difference between the highest and the second highest Emissions (1000 metric ton of CO2 equivalent) of Germany?
Provide a succinct answer. 1.01e+04. What is the difference between the highest and the second highest Emissions (1000 metric ton of CO2 equivalent) in Netherlands?
Your answer should be compact. 1481.2. What is the difference between the highest and the second highest Emissions (1000 metric ton of CO2 equivalent) in Trinidad and Tobago?
Your answer should be very brief. 19.3. What is the difference between the highest and the lowest Emissions (1000 metric ton of CO2 equivalent) of Canada?
Make the answer very short. 9973.1. What is the difference between the highest and the lowest Emissions (1000 metric ton of CO2 equivalent) in Germany?
Make the answer very short. 1.33e+04. What is the difference between the highest and the lowest Emissions (1000 metric ton of CO2 equivalent) of Netherlands?
Make the answer very short. 2398. What is the difference between the highest and the lowest Emissions (1000 metric ton of CO2 equivalent) of Trinidad and Tobago?
Give a very brief answer. 24.7. 